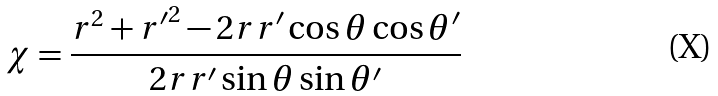Convert formula to latex. <formula><loc_0><loc_0><loc_500><loc_500>\chi = \frac { r ^ { 2 } + { r ^ { \prime } } ^ { 2 } - 2 r r ^ { \prime } \cos \theta \cos \theta ^ { \prime } } { 2 r r ^ { \prime } \sin \theta \sin \theta ^ { \prime } }</formula> 